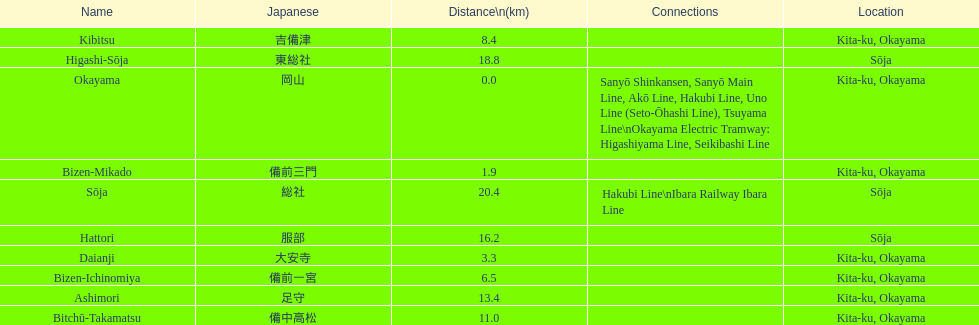How many consecutive stops must you travel through is you board the kibi line at bizen-mikado at depart at kibitsu? 2. 